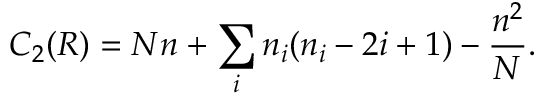Convert formula to latex. <formula><loc_0><loc_0><loc_500><loc_500>C _ { 2 } ( R ) = N n + \sum _ { i } n _ { i } ( n _ { i } - 2 i + 1 ) - \frac { n ^ { 2 } } { N } .</formula> 